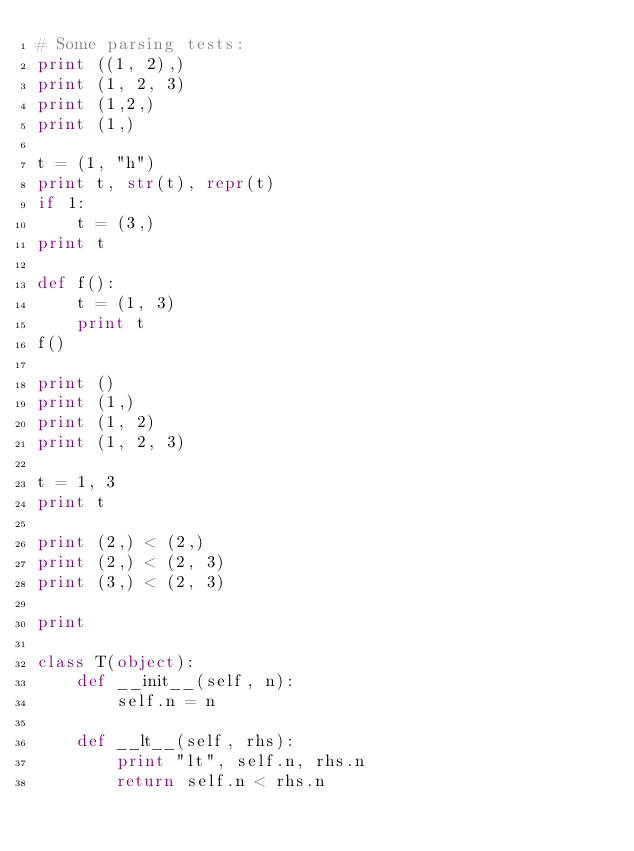Convert code to text. <code><loc_0><loc_0><loc_500><loc_500><_Python_># Some parsing tests:
print ((1, 2),)
print (1, 2, 3)
print (1,2,)
print (1,)

t = (1, "h")
print t, str(t), repr(t)
if 1:
    t = (3,)
print t

def f():
    t = (1, 3)
    print t
f()

print ()
print (1,)
print (1, 2)
print (1, 2, 3)

t = 1, 3
print t

print (2,) < (2,)
print (2,) < (2, 3)
print (3,) < (2, 3)

print

class T(object):
    def __init__(self, n):
        self.n = n

    def __lt__(self, rhs):
        print "lt", self.n, rhs.n
        return self.n < rhs.n
</code> 